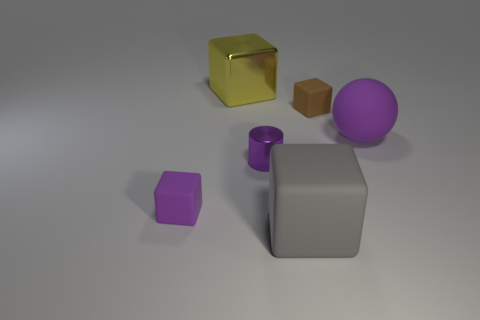Subtract all purple blocks. How many blocks are left? 3 Add 2 brown blocks. How many objects exist? 8 Subtract all cylinders. How many objects are left? 5 Subtract all brown blocks. How many blocks are left? 3 Subtract 0 yellow spheres. How many objects are left? 6 Subtract all gray spheres. Subtract all gray blocks. How many spheres are left? 1 Subtract all blue metal cylinders. Subtract all big gray objects. How many objects are left? 5 Add 5 big metallic cubes. How many big metallic cubes are left? 6 Add 6 large spheres. How many large spheres exist? 7 